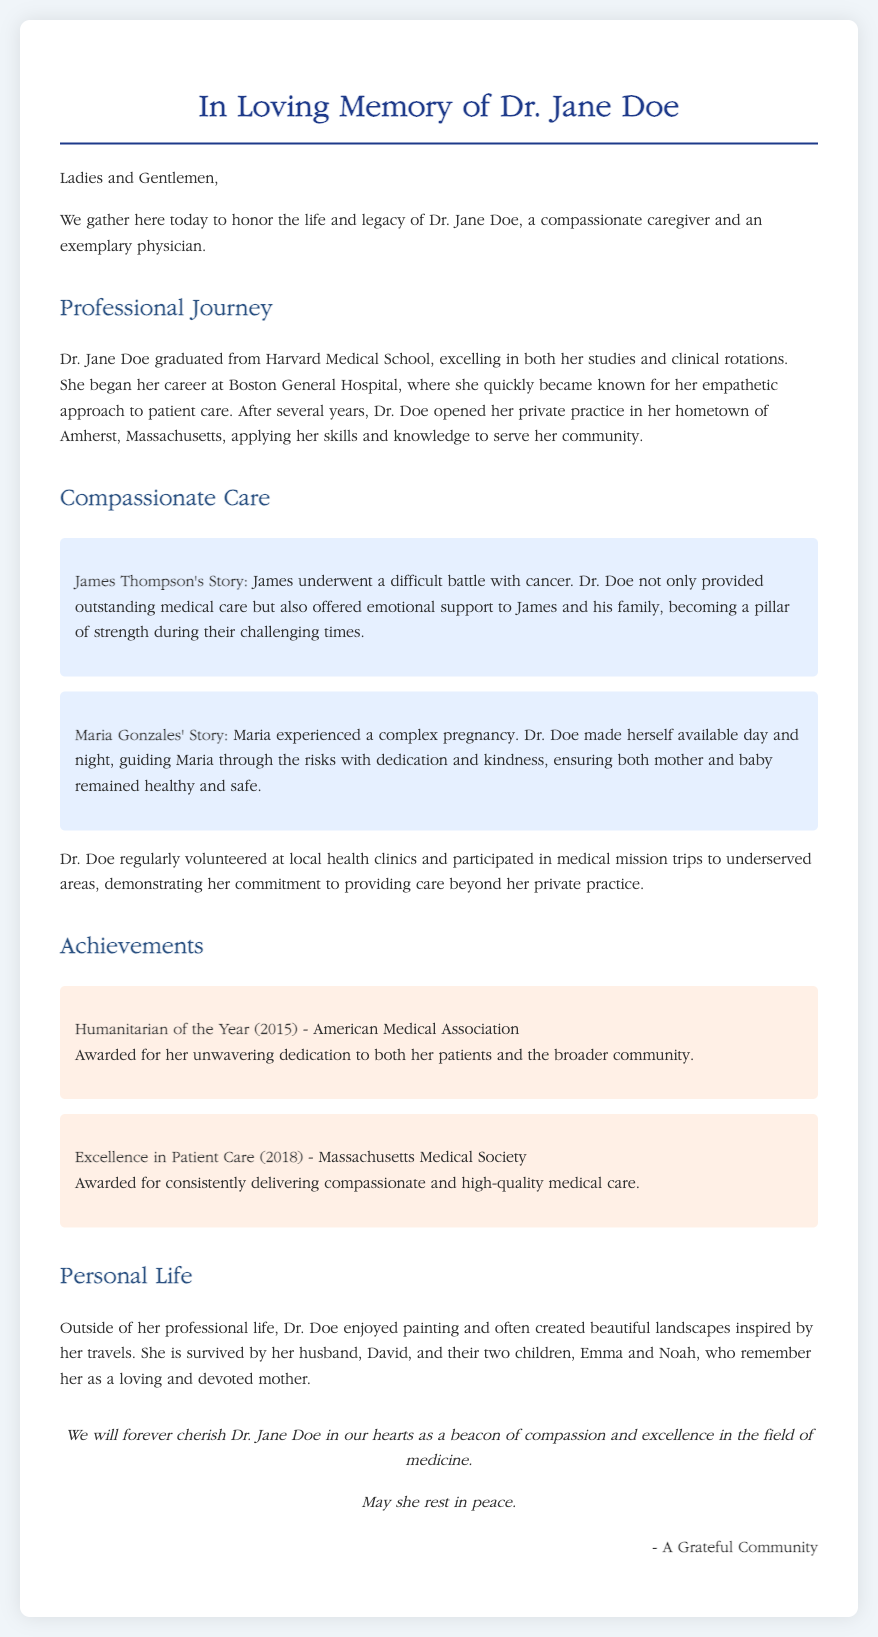what is Dr. Jane Doe’s alma mater? The document states that Dr. Jane Doe graduated from Harvard Medical School.
Answer: Harvard Medical School where did Dr. Doe open her private practice? The document mentions that she opened her private practice in her hometown of Amherst, Massachusetts.
Answer: Amherst, Massachusetts who is a patient of Dr. Doe mentioned in the eulogy? The eulogy includes stories about patients James Thompson and Maria Gonzales.
Answer: James Thompson what award did Dr. Doe receive in 2018? The document indicates that she received the Excellence in Patient Care award in 2018.
Answer: Excellence in Patient Care how many children did Dr. Doe have? The eulogy states that she is survived by her two children, Emma and Noah.
Answer: two why was Dr. Doe recognized as Humanitarian of the Year? The document attributes her recognition to her unwavering dedication to both her patients and the broader community.
Answer: unwavering dedication how did Dr. Doe contribute to her community beyond her practice? The document notes that she volunteered at local health clinics and participated in medical mission trips.
Answer: volunteered and participated in medical mission trips what emotional support did Dr. Doe provide James Thompson? The document describes that Dr. Doe offered emotional support during his difficult battle with cancer.
Answer: emotional support during cancer battle what was Dr. Doe’s hobby outside of medicine? The eulogy states that she enjoyed painting and creating landscapes inspired by her travels.
Answer: painting 